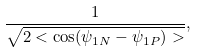Convert formula to latex. <formula><loc_0><loc_0><loc_500><loc_500>\frac { 1 } { \sqrt { 2 < \cos ( \psi _ { 1 N } - \psi _ { 1 P } ) > } } ,</formula> 